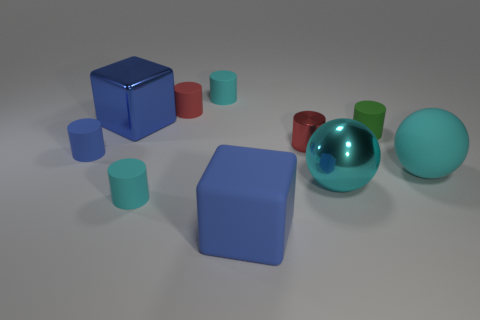Subtract all blue cylinders. How many cylinders are left? 5 Subtract 4 cylinders. How many cylinders are left? 2 Subtract all red cylinders. How many cylinders are left? 4 Subtract all cubes. How many objects are left? 8 Subtract all cyan balls. How many red cylinders are left? 2 Subtract all big cyan matte things. Subtract all blue matte cylinders. How many objects are left? 8 Add 2 large cyan metallic objects. How many large cyan metallic objects are left? 3 Add 4 big metal balls. How many big metal balls exist? 5 Subtract 2 red cylinders. How many objects are left? 8 Subtract all yellow spheres. Subtract all cyan cylinders. How many spheres are left? 2 